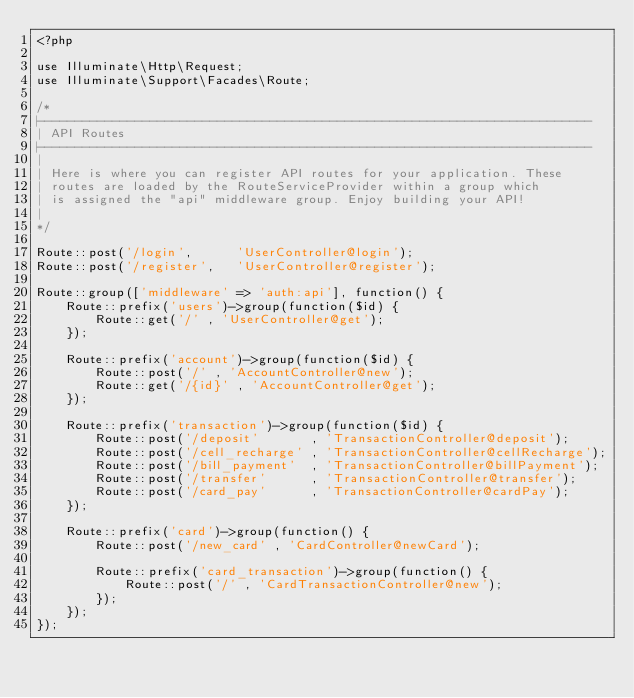<code> <loc_0><loc_0><loc_500><loc_500><_PHP_><?php

use Illuminate\Http\Request;
use Illuminate\Support\Facades\Route;

/*
|--------------------------------------------------------------------------
| API Routes
|--------------------------------------------------------------------------
|
| Here is where you can register API routes for your application. These
| routes are loaded by the RouteServiceProvider within a group which
| is assigned the "api" middleware group. Enjoy building your API!
|
*/

Route::post('/login',      'UserController@login');
Route::post('/register',   'UserController@register');

Route::group(['middleware' => 'auth:api'], function() {
    Route::prefix('users')->group(function($id) {
        Route::get('/' , 'UserController@get');
    });

    Route::prefix('account')->group(function($id) {
        Route::post('/' , 'AccountController@new');
        Route::get('/{id}' , 'AccountController@get');
    });

    Route::prefix('transaction')->group(function($id) {
        Route::post('/deposit'       , 'TransactionController@deposit');
        Route::post('/cell_recharge' , 'TransactionController@cellRecharge');
        Route::post('/bill_payment'  , 'TransactionController@billPayment');
        Route::post('/transfer'      , 'TransactionController@transfer');
        Route::post('/card_pay'      , 'TransactionController@cardPay');
    });

    Route::prefix('card')->group(function() {
        Route::post('/new_card' , 'CardController@newCard');

        Route::prefix('card_transaction')->group(function() {
            Route::post('/' , 'CardTransactionController@new');
        });
    });
});


</code> 